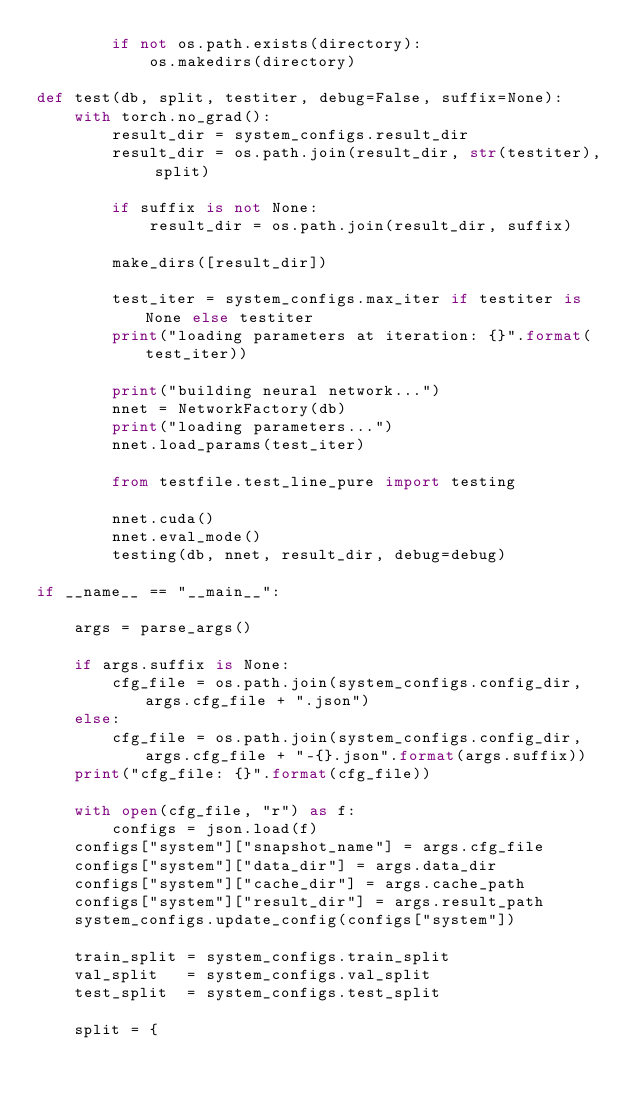<code> <loc_0><loc_0><loc_500><loc_500><_Python_>        if not os.path.exists(directory):
            os.makedirs(directory)

def test(db, split, testiter, debug=False, suffix=None):
    with torch.no_grad():
        result_dir = system_configs.result_dir
        result_dir = os.path.join(result_dir, str(testiter), split)

        if suffix is not None:
            result_dir = os.path.join(result_dir, suffix)

        make_dirs([result_dir])

        test_iter = system_configs.max_iter if testiter is None else testiter
        print("loading parameters at iteration: {}".format(test_iter))

        print("building neural network...")
        nnet = NetworkFactory(db)
        print("loading parameters...")
        nnet.load_params(test_iter)

        from testfile.test_line_pure import testing

        nnet.cuda()
        nnet.eval_mode()
        testing(db, nnet, result_dir, debug=debug)

if __name__ == "__main__":

    args = parse_args()

    if args.suffix is None:
        cfg_file = os.path.join(system_configs.config_dir, args.cfg_file + ".json")
    else:
        cfg_file = os.path.join(system_configs.config_dir, args.cfg_file + "-{}.json".format(args.suffix))
    print("cfg_file: {}".format(cfg_file))

    with open(cfg_file, "r") as f:
        configs = json.load(f)
    configs["system"]["snapshot_name"] = args.cfg_file
    configs["system"]["data_dir"] = args.data_dir
    configs["system"]["cache_dir"] = args.cache_path
    configs["system"]["result_dir"] = args.result_path
    system_configs.update_config(configs["system"])

    train_split = system_configs.train_split
    val_split   = system_configs.val_split
    test_split  = system_configs.test_split

    split = {</code> 